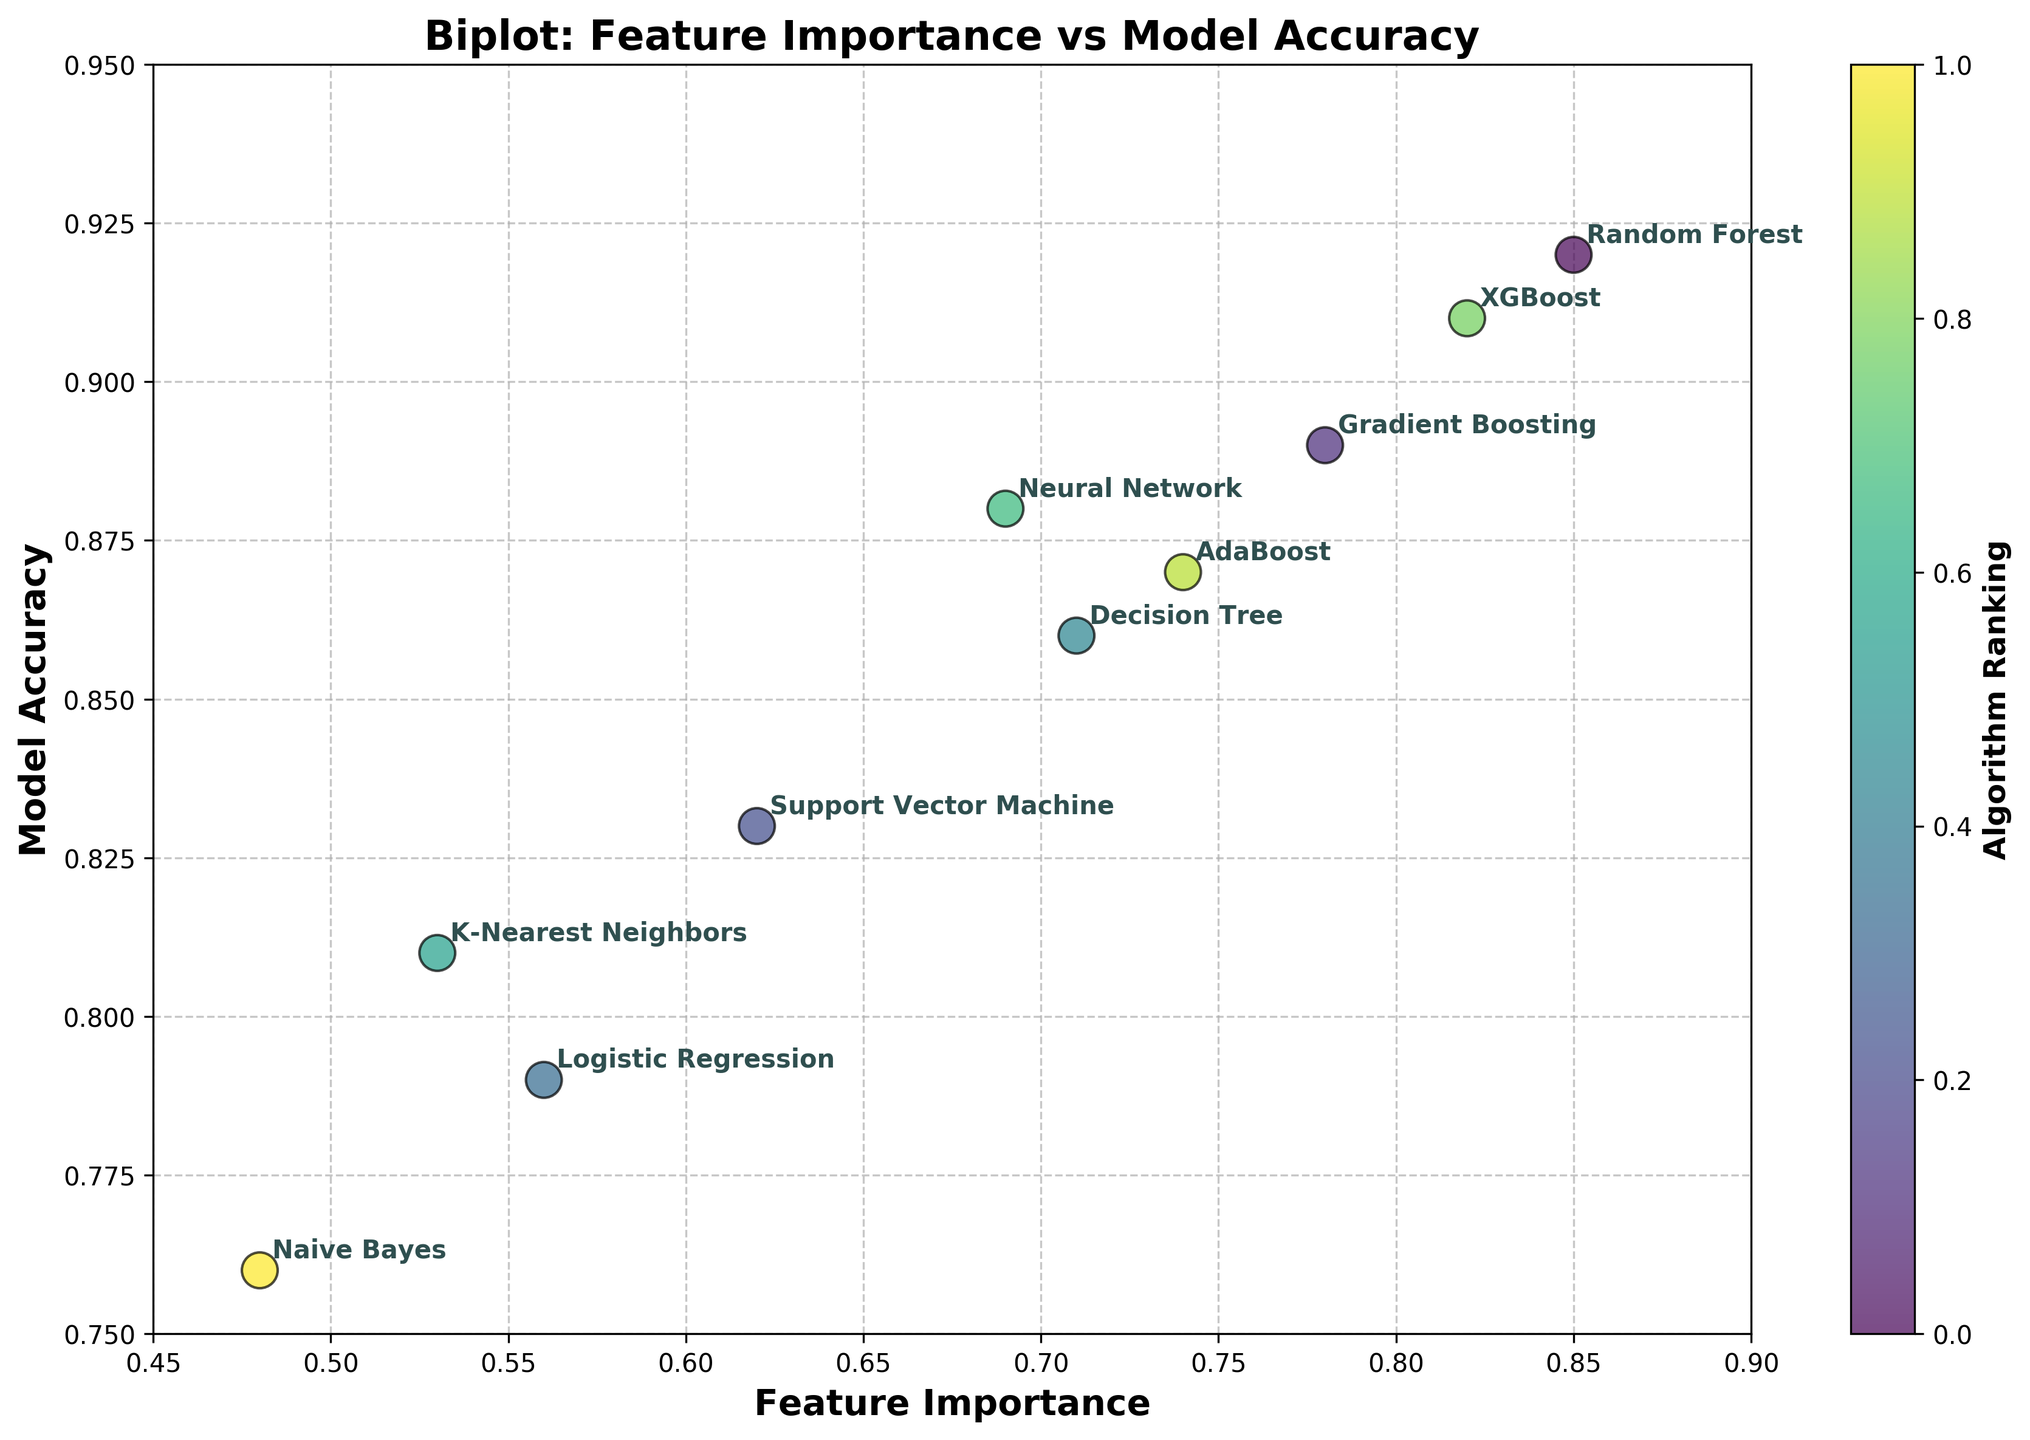What is the title of the plot? The title of the plot is prominently displayed at the top and it usually provides a summary of what the visual display represents.
Answer: Biplot: Feature Importance vs Model Accuracy How many machine learning algorithms are compared in the plot? Count the number of different algorithm names annotated next to the scatter points in the plot. Since there are 10 unique annotations, there are 10 different algorithms shown.
Answer: 10 Which algorithm has the highest feature importance? Identify the point with the highest x-value on the scatter plot and read the corresponding annotation to find the algorithm's name.
Answer: Random Forest What is the model accuracy of the XGBoost algorithm? Find the annotation for "XGBoost" and identify its corresponding y-value on the scatter plot, which represents the model accuracy.
Answer: 0.91 Does the Support Vector Machine algorithm have higher model accuracy than K-Nearest Neighbors? Compare the y-values (model accuracy) of the Support Vector Machine and K-Nearest Neighbors points on the scatter plot.
Answer: Yes What is the difference in feature importance between the Decision Tree and AdaBoost algorithms? Locate both algorithms on the scatter plot, note down their x-values, and compute the difference. Decision Tree: 0.71, AdaBoost: 0.74. Difference = 0.74 - 0.71.
Answer: 0.03 Which algorithm has the lowest model accuracy? Identify the point with the lowest y-value on the scatter plot and read the corresponding annotation to find the algorithm's name.
Answer: Naive Bayes How does the feature importance of Neural Network compare to Logistic Regression? Compare the x-values (feature importance) of Neural Network and Logistic Regression on the scatter plot. Neural Network: 0.69, Logistic Regression: 0.56. Neural Network is higher.
Answer: Neural Network is higher What is the average model accuracy of the algorithms shown? Add up all the y-values (model accuracy) of the points and divide by the number of data points (10) to find the average. (0.92 + 0.89 + 0.83 + 0.79 + 0.86 + 0.81 + 0.88 + 0.91 + 0.87 + 0.76) / 10 = 8.52 / 10 = 0.852
Answer: 0.852 Does a higher feature importance always correspond to a higher model accuracy? Examine the scatter plot to see if there is a consistent trend where points with higher x-values have correspondingly higher y-values. Observing the plot, there is a moderate correlation, but not a strict direct correspondence for all points.
Answer: No 